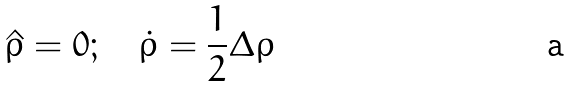<formula> <loc_0><loc_0><loc_500><loc_500>\hat { \rho } = 0 ; \quad \dot { \rho } = \frac { 1 } { 2 } \Delta \rho</formula> 